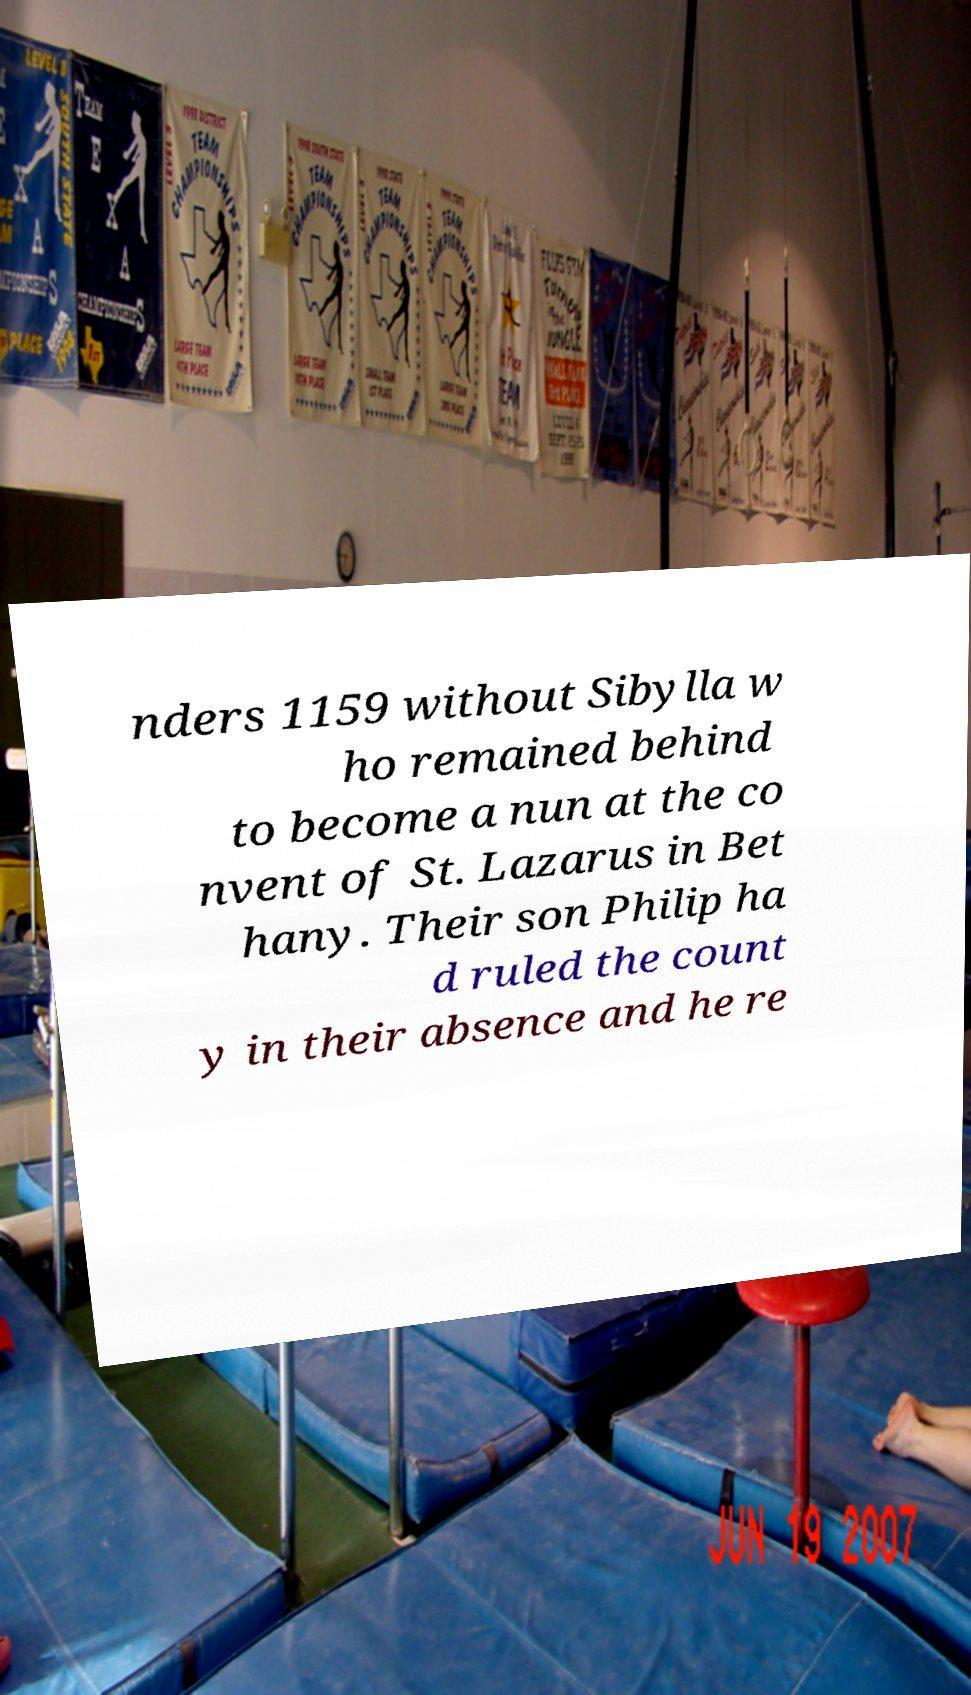There's text embedded in this image that I need extracted. Can you transcribe it verbatim? nders 1159 without Sibylla w ho remained behind to become a nun at the co nvent of St. Lazarus in Bet hany. Their son Philip ha d ruled the count y in their absence and he re 